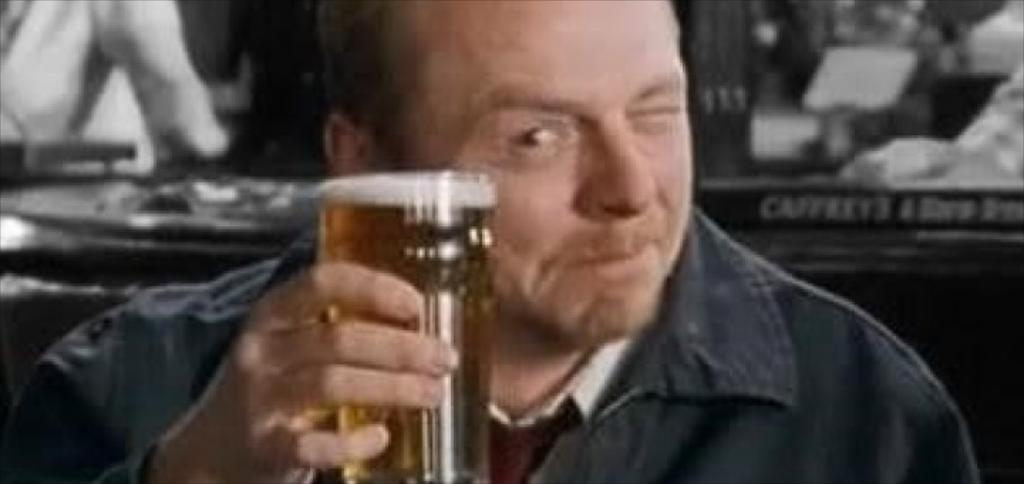What is present in the image? There is a person in the image. What is the person holding? The person is holding a glass. What type of argument is the person having with the clock in the image? There is no clock present in the image, and therefore no argument can be observed. 